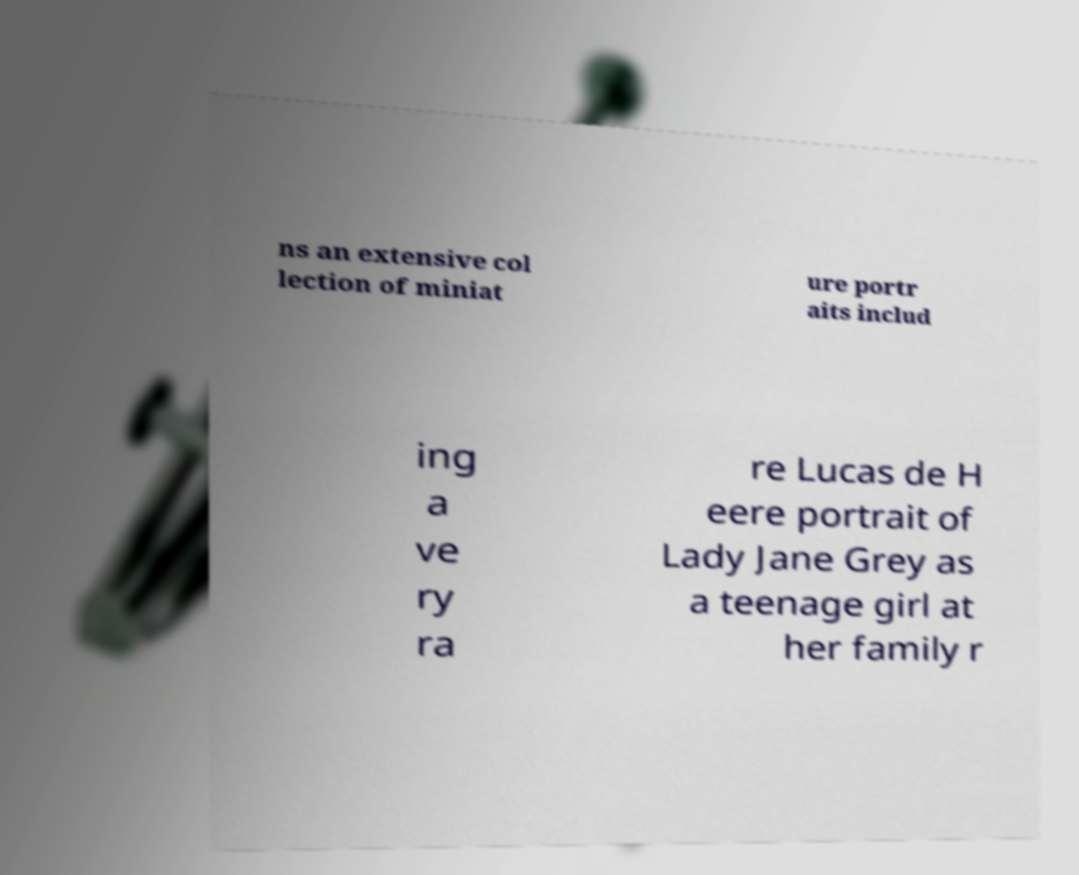Could you assist in decoding the text presented in this image and type it out clearly? ns an extensive col lection of miniat ure portr aits includ ing a ve ry ra re Lucas de H eere portrait of Lady Jane Grey as a teenage girl at her family r 